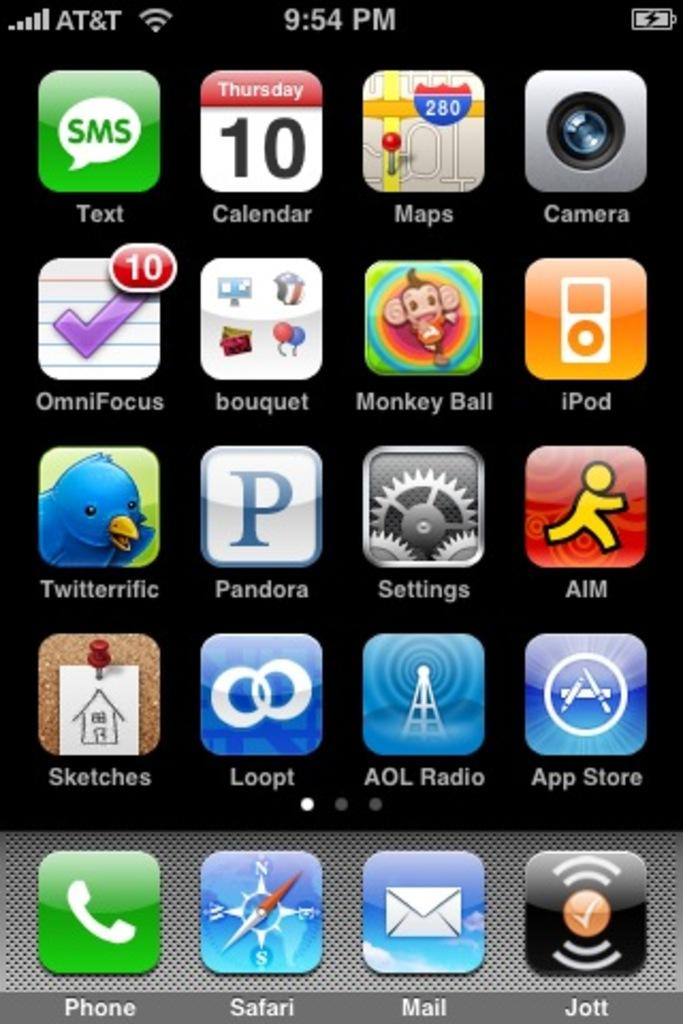<image>
Offer a succinct explanation of the picture presented. A screen shot of iPhone apps from a phone running on the AT&T network. 